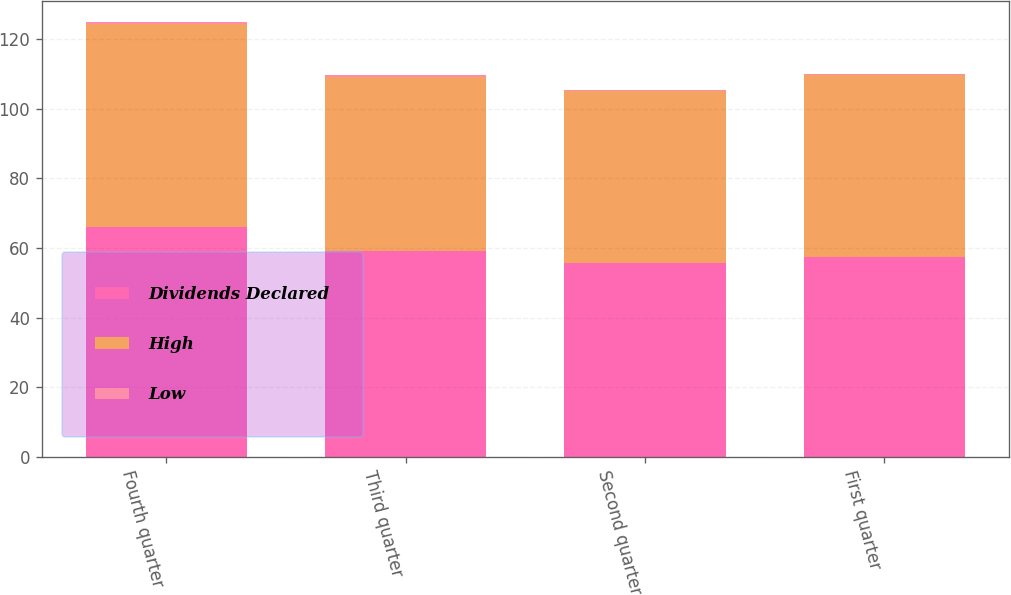Convert chart. <chart><loc_0><loc_0><loc_500><loc_500><stacked_bar_chart><ecel><fcel>Fourth quarter<fcel>Third quarter<fcel>Second quarter<fcel>First quarter<nl><fcel>Dividends Declared<fcel>65.88<fcel>59.24<fcel>55.56<fcel>57.43<nl><fcel>High<fcel>58.55<fcel>50.02<fcel>49.47<fcel>52.23<nl><fcel>Low<fcel>0.44<fcel>0.44<fcel>0.44<fcel>0.44<nl></chart> 